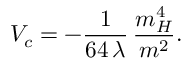Convert formula to latex. <formula><loc_0><loc_0><loc_500><loc_500>V _ { c } = - \frac { 1 } { 6 4 \, \lambda } \, \frac { m _ { H } ^ { 4 } } { m ^ { 2 } } .</formula> 